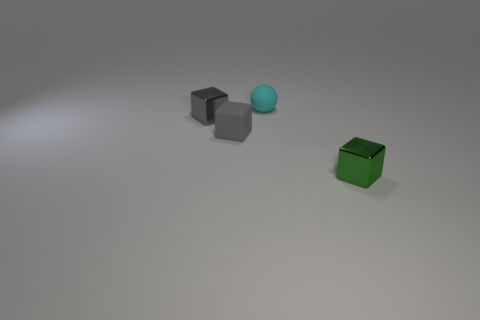Subtract all gray matte cubes. How many cubes are left? 2 Subtract all green cubes. How many cubes are left? 2 Add 1 small cyan rubber balls. How many objects exist? 5 Subtract all cubes. How many objects are left? 1 Subtract 0 green cylinders. How many objects are left? 4 Subtract all brown spheres. Subtract all brown cylinders. How many spheres are left? 1 Subtract all yellow cubes. How many purple spheres are left? 0 Subtract all tiny gray metallic blocks. Subtract all small green metal objects. How many objects are left? 2 Add 4 gray metallic cubes. How many gray metallic cubes are left? 5 Add 3 small purple cubes. How many small purple cubes exist? 3 